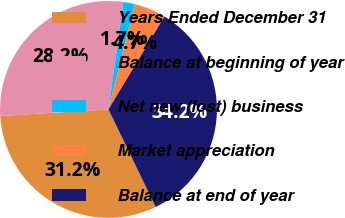Convert chart. <chart><loc_0><loc_0><loc_500><loc_500><pie_chart><fcel>Years Ended December 31<fcel>Balance at beginning of year<fcel>Net new (lost) business<fcel>Market appreciation<fcel>Balance at end of year<nl><fcel>31.19%<fcel>28.17%<fcel>1.71%<fcel>4.72%<fcel>34.2%<nl></chart> 